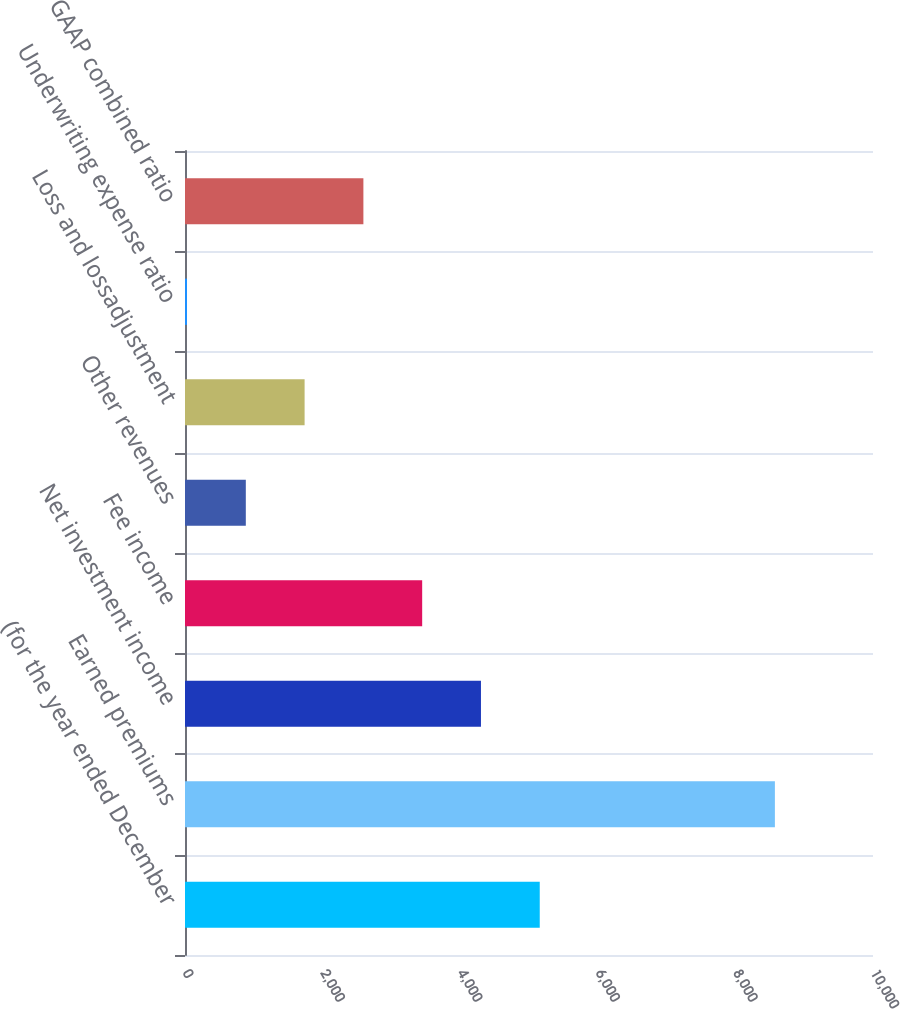Convert chart to OTSL. <chart><loc_0><loc_0><loc_500><loc_500><bar_chart><fcel>(for the year ended December<fcel>Earned premiums<fcel>Net investment income<fcel>Fee income<fcel>Other revenues<fcel>Loss and lossadjustment<fcel>Underwriting expense ratio<fcel>GAAP combined ratio<nl><fcel>5156.2<fcel>8574<fcel>4301.75<fcel>3447.3<fcel>883.95<fcel>1738.4<fcel>29.5<fcel>2592.85<nl></chart> 